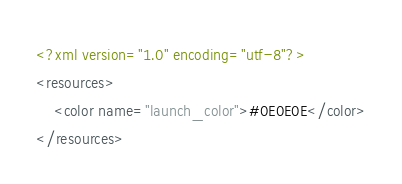<code> <loc_0><loc_0><loc_500><loc_500><_XML_><?xml version="1.0" encoding="utf-8"?>
<resources>
    <color name="launch_color">#0E0E0E</color>
</resources></code> 